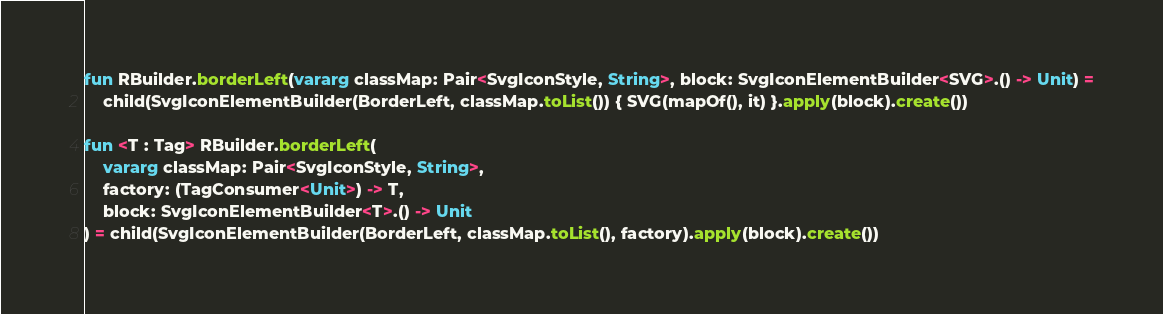Convert code to text. <code><loc_0><loc_0><loc_500><loc_500><_Kotlin_>fun RBuilder.borderLeft(vararg classMap: Pair<SvgIconStyle, String>, block: SvgIconElementBuilder<SVG>.() -> Unit) =
    child(SvgIconElementBuilder(BorderLeft, classMap.toList()) { SVG(mapOf(), it) }.apply(block).create())

fun <T : Tag> RBuilder.borderLeft(
    vararg classMap: Pair<SvgIconStyle, String>,
    factory: (TagConsumer<Unit>) -> T,
    block: SvgIconElementBuilder<T>.() -> Unit
) = child(SvgIconElementBuilder(BorderLeft, classMap.toList(), factory).apply(block).create())
</code> 